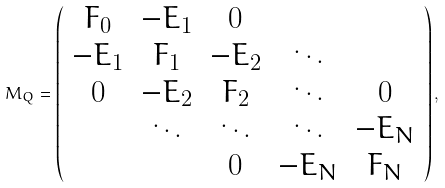Convert formula to latex. <formula><loc_0><loc_0><loc_500><loc_500>M _ { Q } = \left ( \begin{array} { c c c c c } F _ { 0 } & - E _ { 1 } & 0 & & \\ - E _ { 1 } & F _ { 1 } & - E _ { 2 } & \ddots & \\ 0 & - E _ { 2 } & F _ { 2 } & \ddots & 0 \\ & \ddots & \ddots & \ddots & - E _ { N } \\ & & 0 & - E _ { N } & F _ { N } \end{array} \right ) ,</formula> 